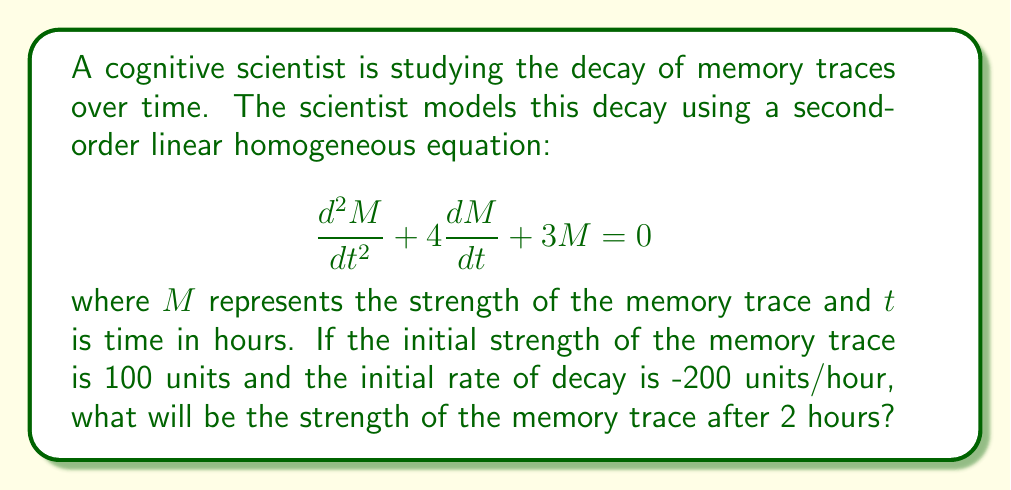Solve this math problem. To solve this problem, we need to follow these steps:

1) First, we need to find the general solution to the homogeneous equation. The characteristic equation is:

   $$r^2 + 4r + 3 = 0$$

2) Solving this quadratic equation:
   
   $$r = \frac{-4 \pm \sqrt{16 - 12}}{2} = \frac{-4 \pm 2}{2}$$
   
   $$r_1 = -1, r_2 = -3$$

3) Therefore, the general solution is:

   $$M(t) = c_1e^{-t} + c_2e^{-3t}$$

4) Now we need to use the initial conditions to find $c_1$ and $c_2$:
   
   At $t=0$, $M(0) = 100$, so:
   $$100 = c_1 + c_2$$

   Also, $M'(t) = -c_1e^{-t} - 3c_2e^{-3t}$
   At $t=0$, $M'(0) = -200$, so:
   $$-200 = -c_1 - 3c_2$$

5) Solving these simultaneous equations:
   
   From the second equation: $c_1 = 200 - 3c_2$
   Substituting into the first equation:
   $100 = (200 - 3c_2) + c_2$
   $100 = 200 - 2c_2$
   $c_2 = 50$
   Therefore, $c_1 = 50$ as well

6) Our particular solution is thus:

   $$M(t) = 50e^{-t} + 50e^{-3t}$$

7) To find the strength after 2 hours, we evaluate $M(2)$:

   $$M(2) = 50e^{-2} + 50e^{-6}$$

8) Calculating this:

   $$M(2) = 50(0.1353) + 50(0.0025) = 6.765 + 0.125 = 6.89$$
Answer: The strength of the memory trace after 2 hours will be approximately 6.89 units. 